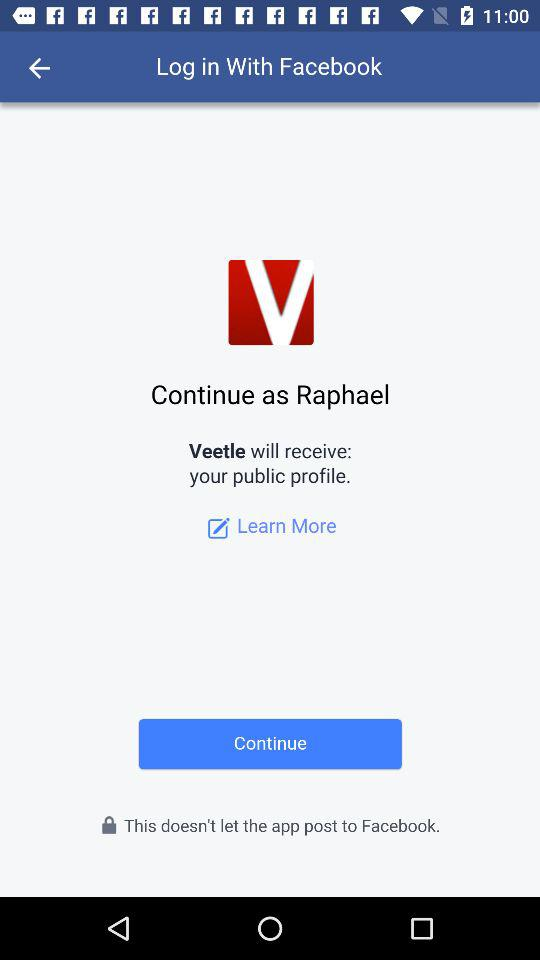What application is used to log in? The application is "Facebook". 